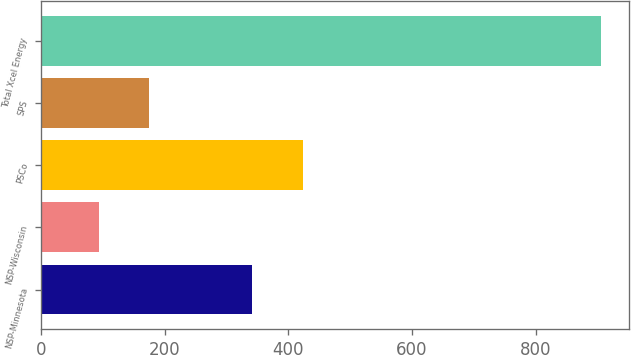Convert chart to OTSL. <chart><loc_0><loc_0><loc_500><loc_500><bar_chart><fcel>NSP-Minnesota<fcel>NSP-Wisconsin<fcel>PSCo<fcel>SPS<fcel>Total Xcel Energy<nl><fcel>342<fcel>94<fcel>423.2<fcel>175.2<fcel>906<nl></chart> 